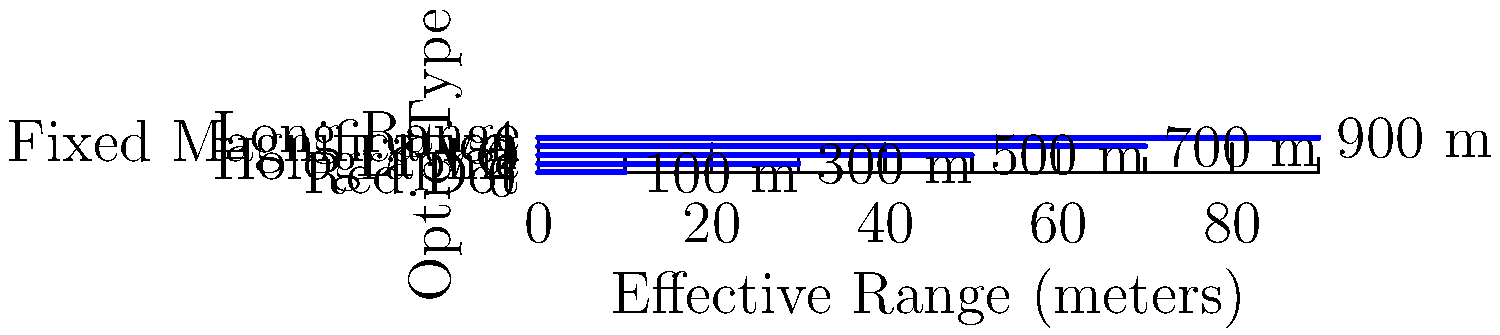Based on the graph showing the effective ranges of different tactical optics, which type of optic would be most suitable for a marksman engaging targets at approximately 600 meters? To determine the most suitable optic for engaging targets at 600 meters, let's analyze the effective ranges shown in the graph:

1. Red Dot: Effective up to 100 meters
2. Holographic: Effective up to 300 meters
3. LPVO (Low Power Variable Optic): Effective up to 500 meters
4. Fixed Magnification: Effective up to 700 meters
5. Long Range: Effective up to 900 meters

The target distance of 600 meters exceeds the effective range of:
- Red Dot
- Holographic
- LPVO

The Fixed Magnification optic has an effective range of 700 meters, which comfortably covers the 600-meter target distance.

The Long Range optic also covers this distance but may be unnecessary for this particular engagement.

Therefore, the most suitable optic for engaging targets at 600 meters would be the Fixed Magnification optic. It provides sufficient range without being overpowered for the given distance.
Answer: Fixed Magnification optic 